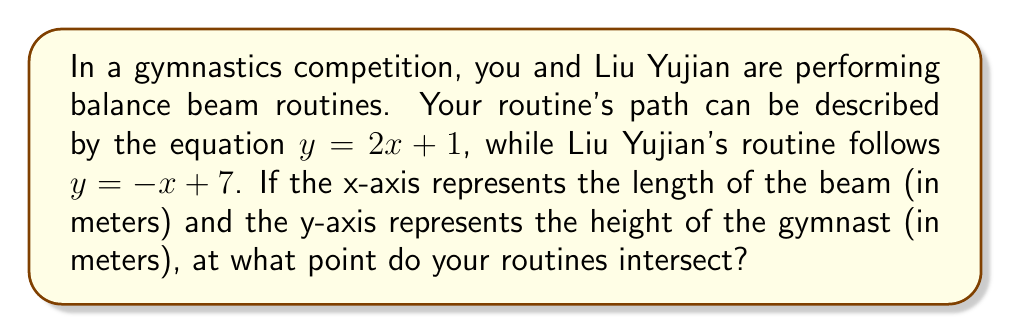What is the answer to this math problem? To find the intersection point of the two balance beam routines, we need to solve the system of equations:

$$\begin{cases}
y = 2x + 1 \\
y = -x + 7
\end{cases}$$

1) Since both equations are equal to y, we can set them equal to each other:

   $2x + 1 = -x + 7$

2) Add x to both sides:

   $3x + 1 = 7$

3) Subtract 1 from both sides:

   $3x = 6$

4) Divide both sides by 3:

   $x = 2$

5) Now that we know x, we can substitute it into either of the original equations. Let's use the first one:

   $y = 2(2) + 1 = 4 + 1 = 5$

6) Therefore, the intersection point is (2, 5).

This means your routines intersect 2 meters along the length of the beam and at a height of 5 meters.
Answer: (2, 5) 